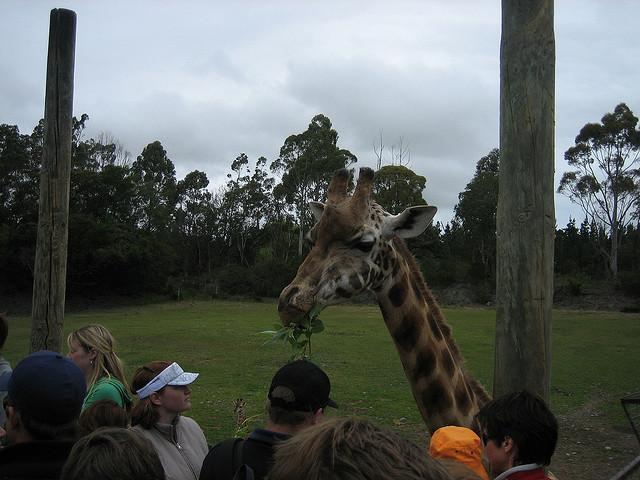How many people are there?
Give a very brief answer. 7. How many blue cakes are visible?
Give a very brief answer. 0. 